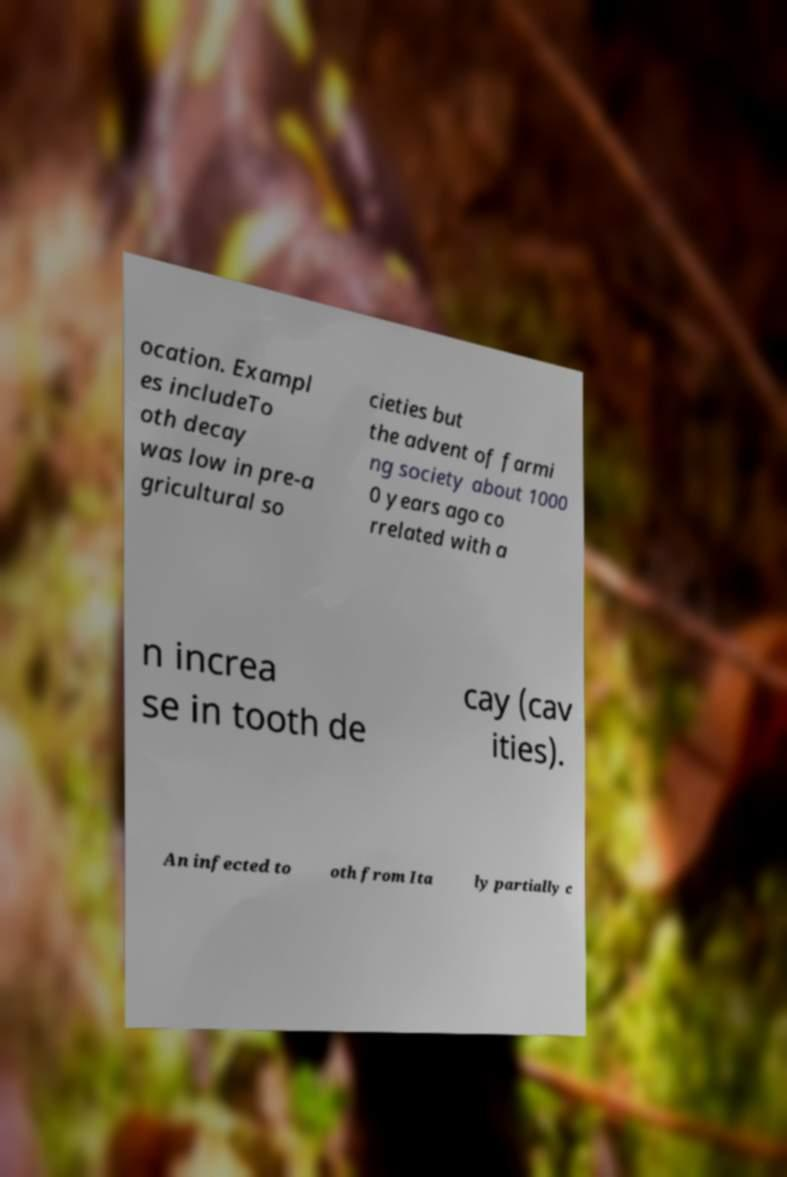Can you read and provide the text displayed in the image?This photo seems to have some interesting text. Can you extract and type it out for me? ocation. Exampl es includeTo oth decay was low in pre-a gricultural so cieties but the advent of farmi ng society about 1000 0 years ago co rrelated with a n increa se in tooth de cay (cav ities). An infected to oth from Ita ly partially c 